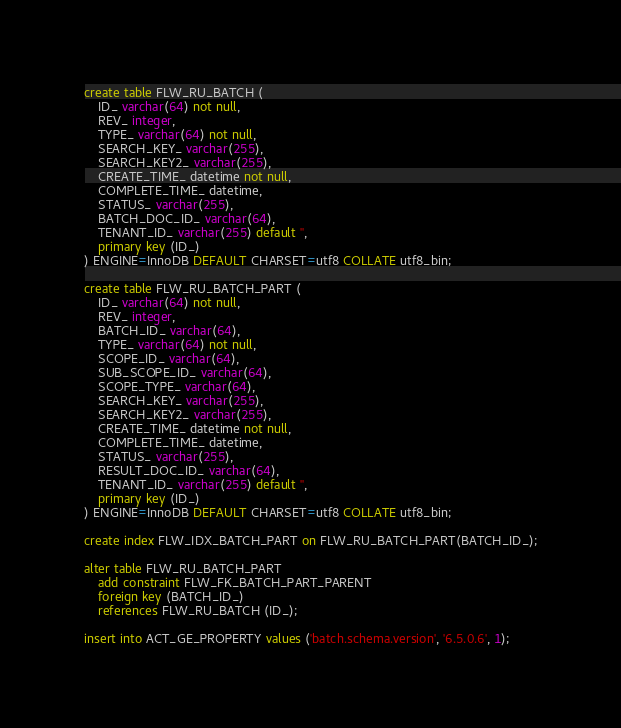<code> <loc_0><loc_0><loc_500><loc_500><_SQL_>create table FLW_RU_BATCH (
    ID_ varchar(64) not null,
    REV_ integer,
    TYPE_ varchar(64) not null,
    SEARCH_KEY_ varchar(255),
    SEARCH_KEY2_ varchar(255),
    CREATE_TIME_ datetime not null,
    COMPLETE_TIME_ datetime,
    STATUS_ varchar(255),
    BATCH_DOC_ID_ varchar(64),
    TENANT_ID_ varchar(255) default '',
    primary key (ID_)
) ENGINE=InnoDB DEFAULT CHARSET=utf8 COLLATE utf8_bin;

create table FLW_RU_BATCH_PART (
    ID_ varchar(64) not null,
    REV_ integer,
    BATCH_ID_ varchar(64),
    TYPE_ varchar(64) not null,
    SCOPE_ID_ varchar(64),
    SUB_SCOPE_ID_ varchar(64),
    SCOPE_TYPE_ varchar(64),
    SEARCH_KEY_ varchar(255),
    SEARCH_KEY2_ varchar(255),
    CREATE_TIME_ datetime not null,
    COMPLETE_TIME_ datetime,
    STATUS_ varchar(255),
    RESULT_DOC_ID_ varchar(64),
    TENANT_ID_ varchar(255) default '',
    primary key (ID_)
) ENGINE=InnoDB DEFAULT CHARSET=utf8 COLLATE utf8_bin;

create index FLW_IDX_BATCH_PART on FLW_RU_BATCH_PART(BATCH_ID_);

alter table FLW_RU_BATCH_PART
    add constraint FLW_FK_BATCH_PART_PARENT
    foreign key (BATCH_ID_)
    references FLW_RU_BATCH (ID_);

insert into ACT_GE_PROPERTY values ('batch.schema.version', '6.5.0.6', 1);
</code> 